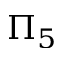Convert formula to latex. <formula><loc_0><loc_0><loc_500><loc_500>\Pi _ { 5 }</formula> 